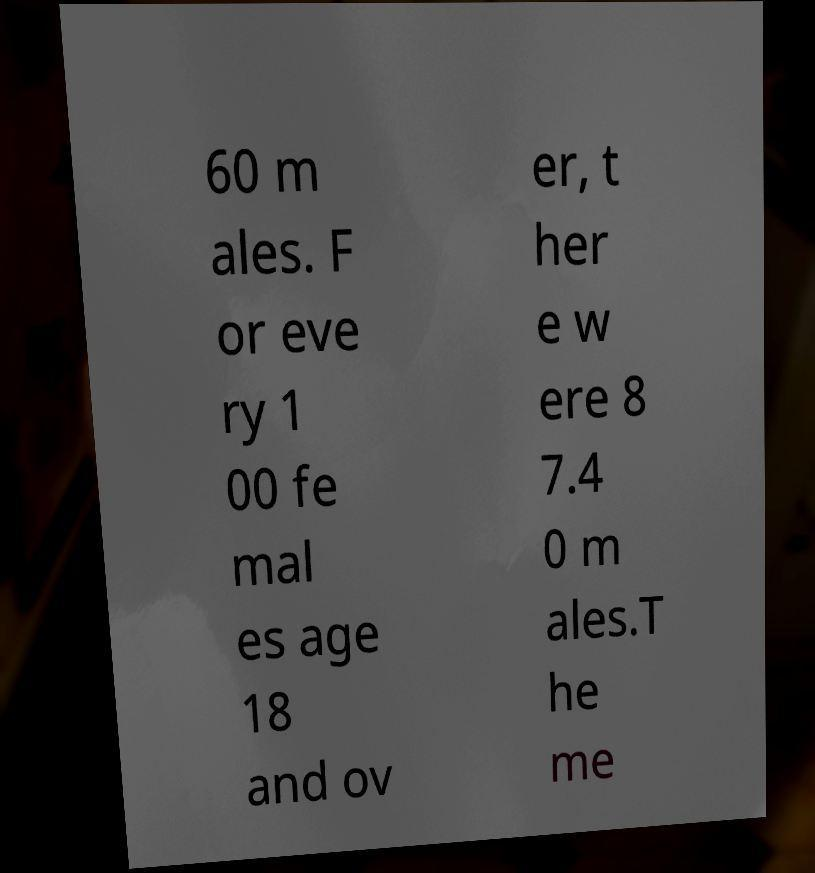Can you accurately transcribe the text from the provided image for me? 60 m ales. F or eve ry 1 00 fe mal es age 18 and ov er, t her e w ere 8 7.4 0 m ales.T he me 